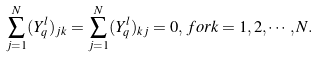<formula> <loc_0><loc_0><loc_500><loc_500>\sum _ { j = 1 } ^ { N } ( Y _ { q } ^ { l } ) _ { j k } = \sum _ { j = 1 } ^ { N } ( Y _ { q } ^ { l } ) _ { k j } = 0 , \, f o r k = 1 , 2 , \cdots , N .</formula> 